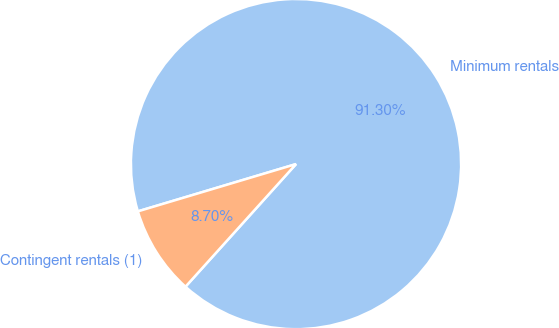<chart> <loc_0><loc_0><loc_500><loc_500><pie_chart><fcel>Minimum rentals<fcel>Contingent rentals (1)<nl><fcel>91.3%<fcel>8.7%<nl></chart> 